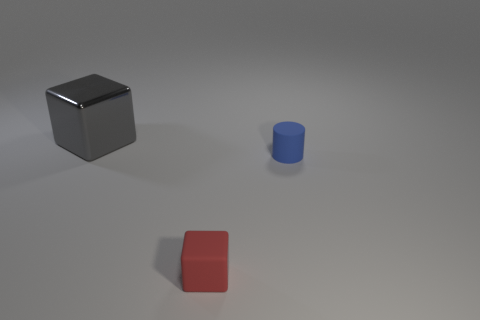Add 2 small blue rubber objects. How many objects exist? 5 Subtract all cylinders. How many objects are left? 2 Subtract all gray blocks. Subtract all big gray things. How many objects are left? 1 Add 2 small blue rubber cylinders. How many small blue rubber cylinders are left? 3 Add 3 small blue rubber cylinders. How many small blue rubber cylinders exist? 4 Subtract 0 yellow cylinders. How many objects are left? 3 